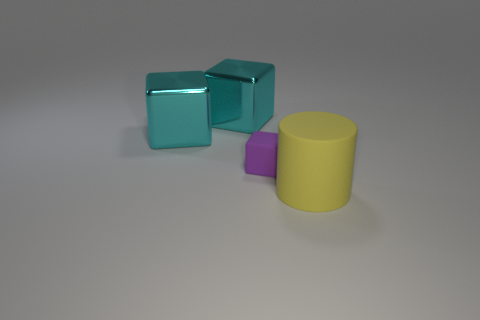What might these objects be used for? These objects could be used for a variety of purposes depending on their material and size in real life. They may serve as children's blocks, decorative pieces, or even components in an artistic installation. However, without further information, their functionality remains open to interpretation. 